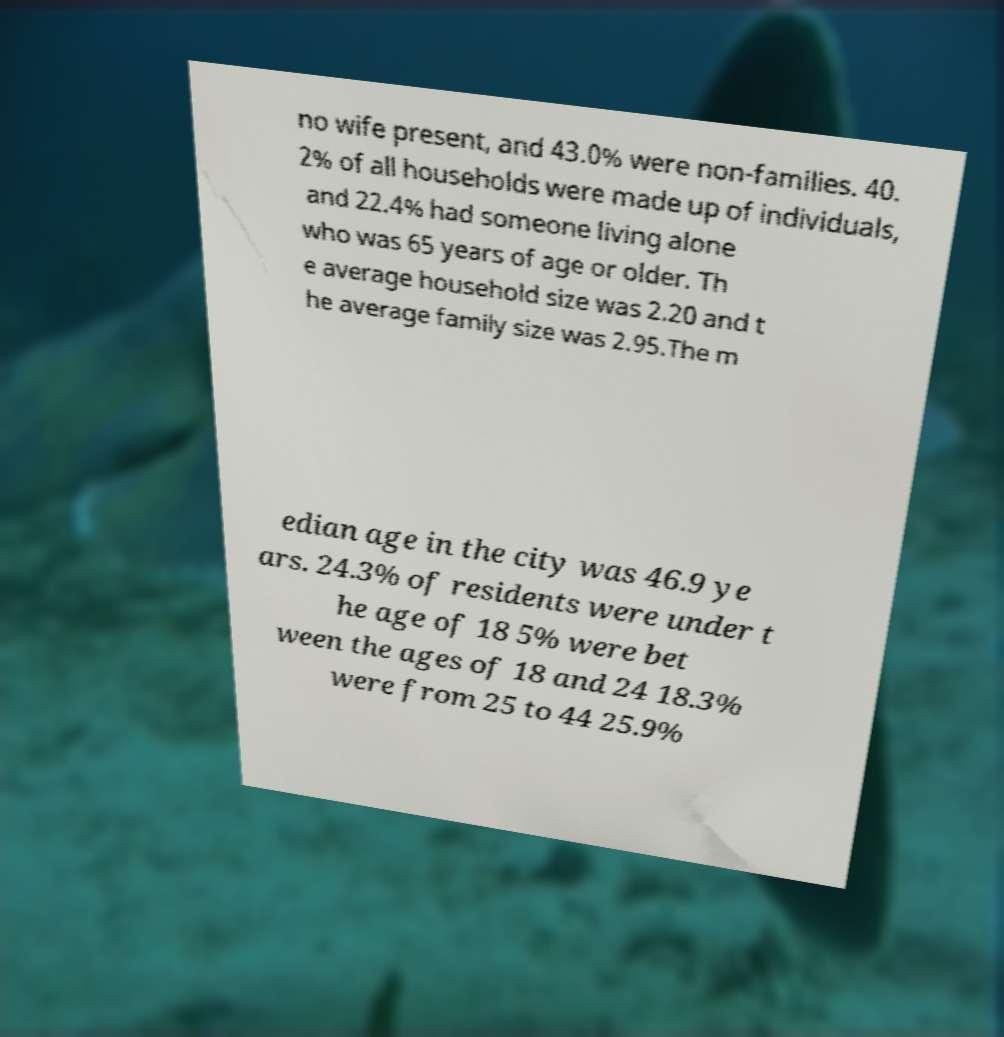What messages or text are displayed in this image? I need them in a readable, typed format. no wife present, and 43.0% were non-families. 40. 2% of all households were made up of individuals, and 22.4% had someone living alone who was 65 years of age or older. Th e average household size was 2.20 and t he average family size was 2.95.The m edian age in the city was 46.9 ye ars. 24.3% of residents were under t he age of 18 5% were bet ween the ages of 18 and 24 18.3% were from 25 to 44 25.9% 